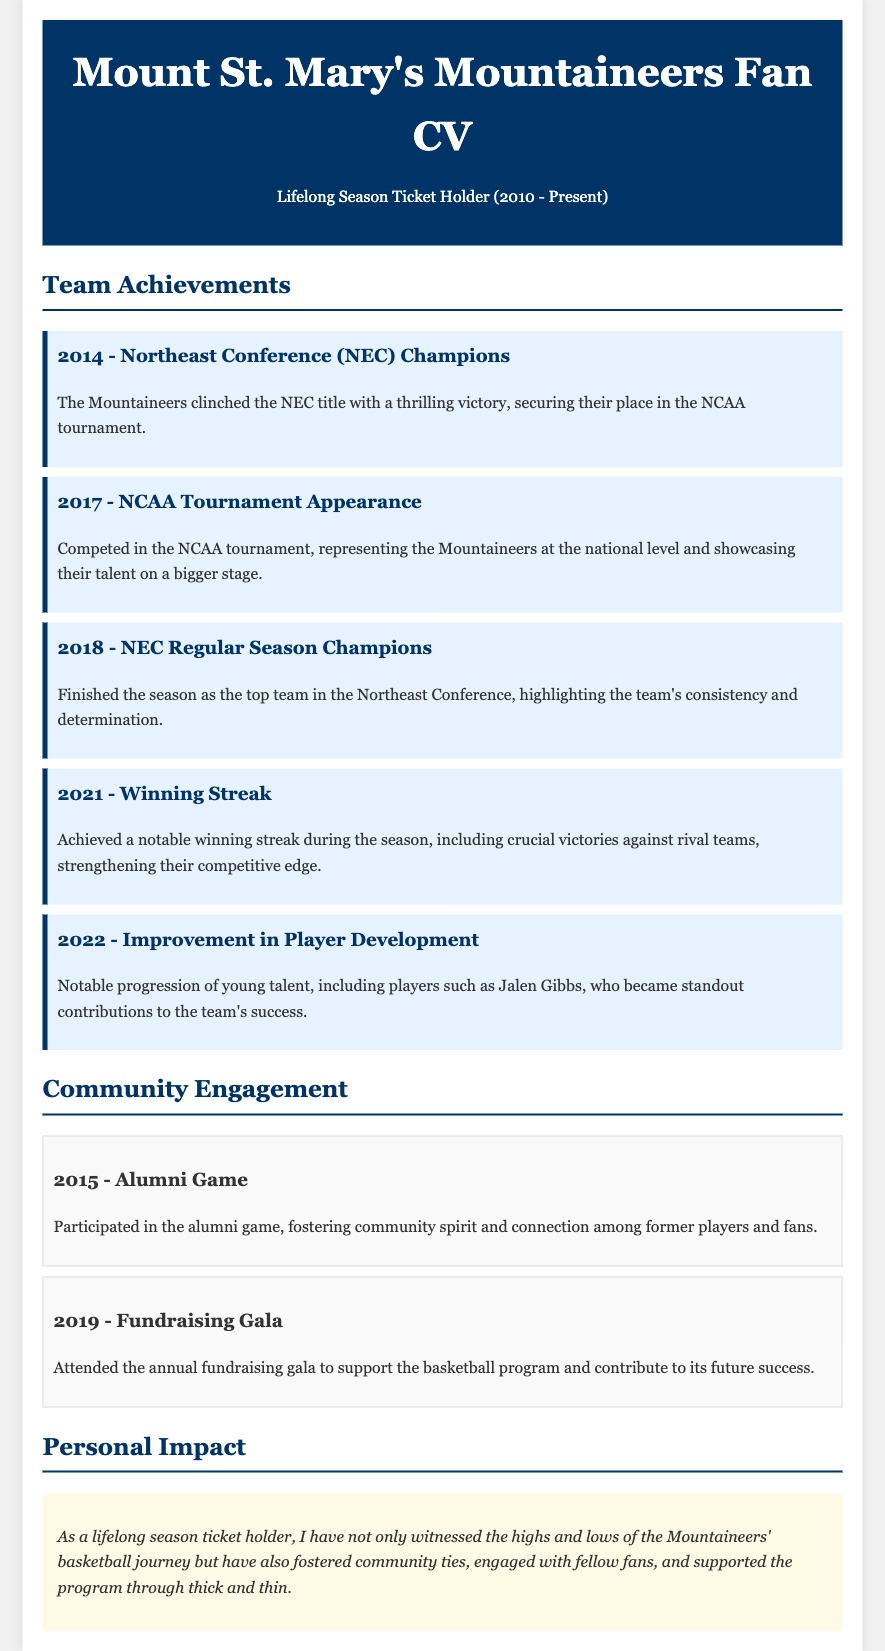What championship did Mount St. Mary's win in 2014? The document notes that the Mountaineers clinched the NEC title in 2014.
Answer: NEC Champions What notable event occurred for the team in 2017? According to the document, the Mountaineers competed in the NCAA tournament in 2017.
Answer: NCAA Tournament Appearance Which season did the Mountaineers finish as the top team in the NEC? The document states that they finished as the top team in the Northeast Conference in 2018.
Answer: 2018 What significant streak did the team achieve in 2021? The document mentions the team had a notable winning streak during the 2021 season.
Answer: Winning Streak Who is mentioned as a standout contributor in 2022? The document highlights Jalen Gibbs as a notable player in 2022.
Answer: Jalen Gibbs In what year did the alumni game take place? The document indicates the alumni game occurred in 2015.
Answer: 2015 What community event did fans attend in 2019? The document mentions that fans attended the annual fundraising gala in 2019.
Answer: Fundraising Gala What personal experience does the ticket holder share in their impact statement? The document conveys that the ticket holder has witnessed the highs and lows of the Mountaineers' journey.
Answer: Witnessed highs and lows How long has the individual held season tickets? The document states the individual has been a season ticket holder since 2010.
Answer: Since 2010 